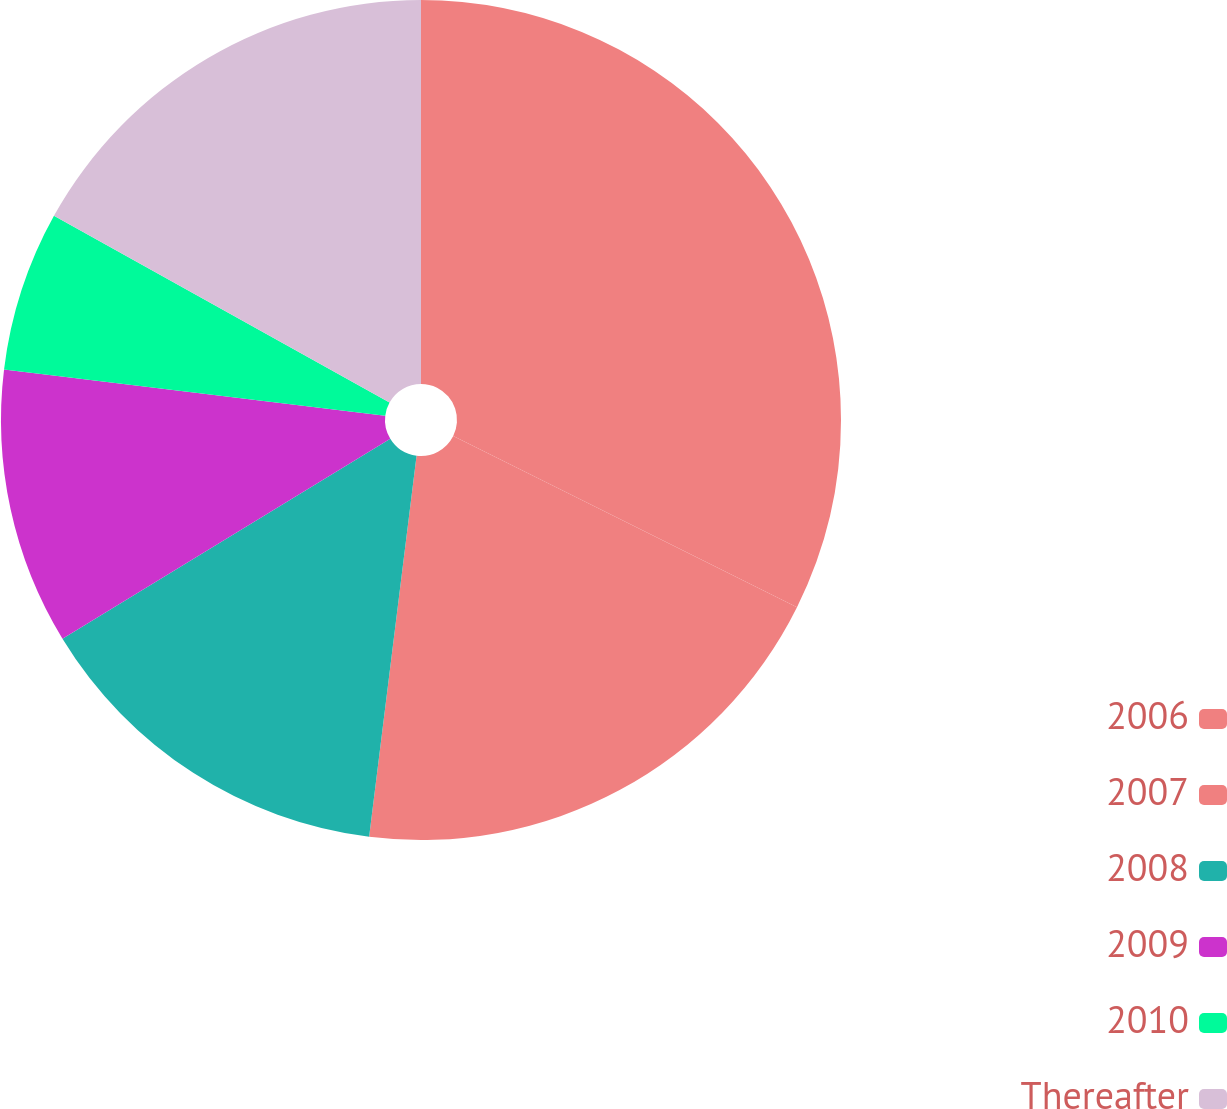<chart> <loc_0><loc_0><loc_500><loc_500><pie_chart><fcel>2006<fcel>2007<fcel>2008<fcel>2009<fcel>2010<fcel>Thereafter<nl><fcel>32.35%<fcel>19.62%<fcel>14.31%<fcel>10.64%<fcel>6.16%<fcel>16.92%<nl></chart> 